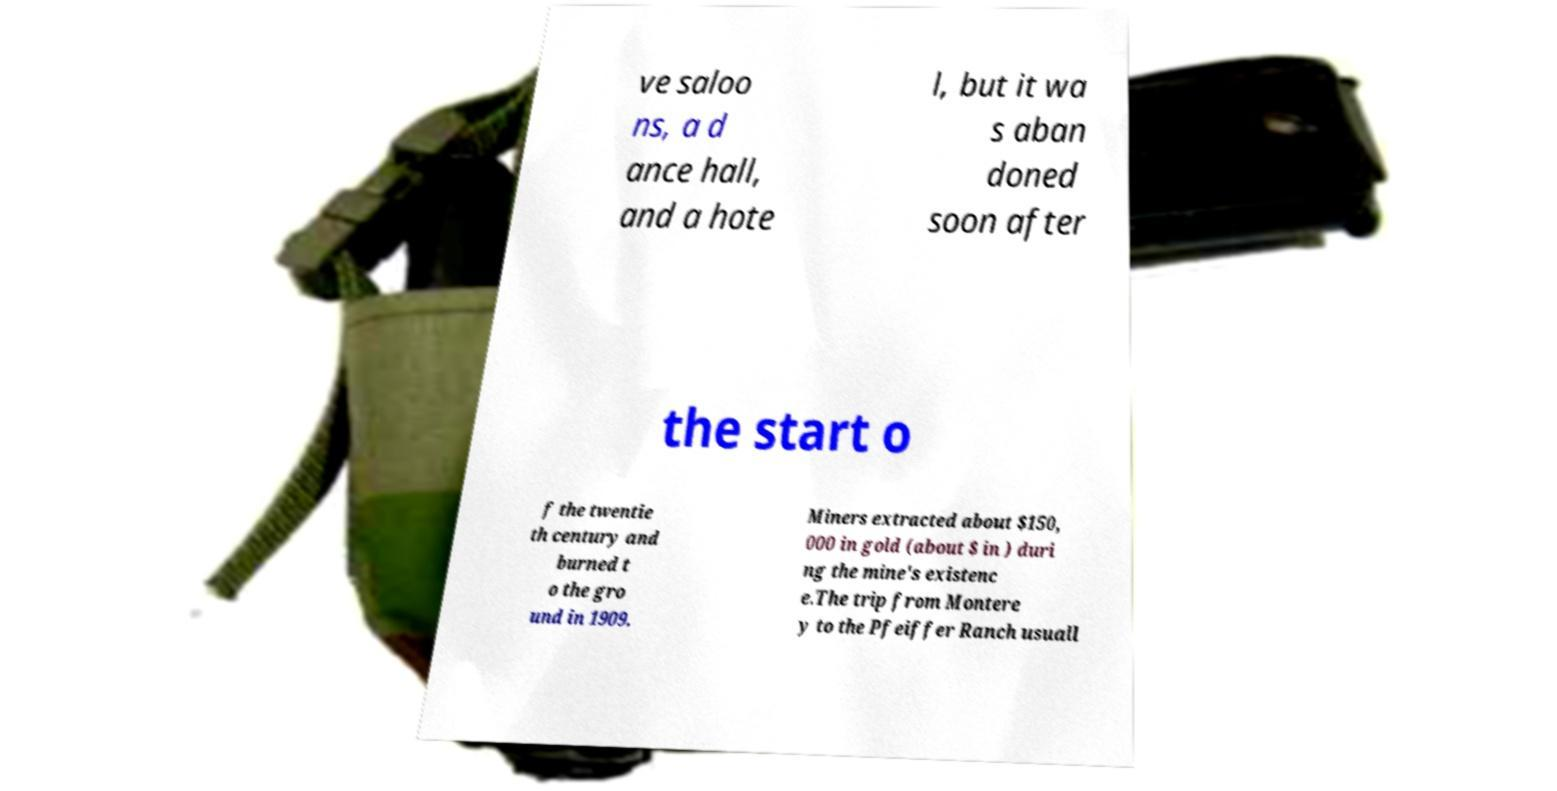Could you extract and type out the text from this image? ve saloo ns, a d ance hall, and a hote l, but it wa s aban doned soon after the start o f the twentie th century and burned t o the gro und in 1909. Miners extracted about $150, 000 in gold (about $ in ) duri ng the mine's existenc e.The trip from Montere y to the Pfeiffer Ranch usuall 